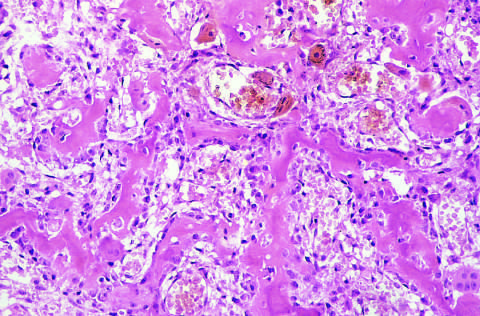re the intertrabecular spaces filled by vascularized loose connective tissue?
Answer the question using a single word or phrase. Yes 